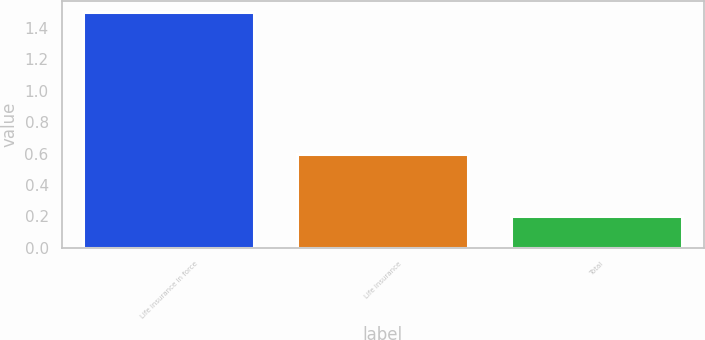Convert chart. <chart><loc_0><loc_0><loc_500><loc_500><bar_chart><fcel>Life insurance in force<fcel>Life insurance<fcel>Total<nl><fcel>1.5<fcel>0.6<fcel>0.2<nl></chart> 